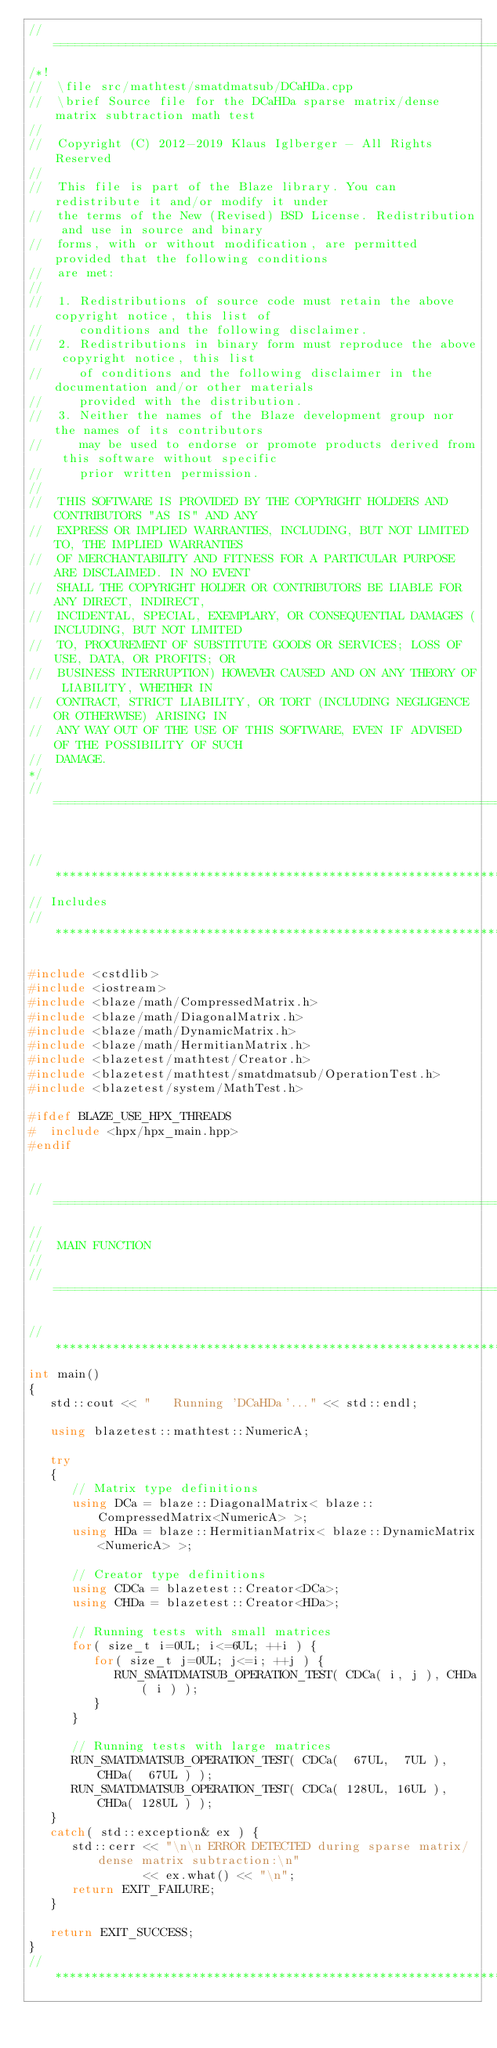<code> <loc_0><loc_0><loc_500><loc_500><_C++_>//=================================================================================================
/*!
//  \file src/mathtest/smatdmatsub/DCaHDa.cpp
//  \brief Source file for the DCaHDa sparse matrix/dense matrix subtraction math test
//
//  Copyright (C) 2012-2019 Klaus Iglberger - All Rights Reserved
//
//  This file is part of the Blaze library. You can redistribute it and/or modify it under
//  the terms of the New (Revised) BSD License. Redistribution and use in source and binary
//  forms, with or without modification, are permitted provided that the following conditions
//  are met:
//
//  1. Redistributions of source code must retain the above copyright notice, this list of
//     conditions and the following disclaimer.
//  2. Redistributions in binary form must reproduce the above copyright notice, this list
//     of conditions and the following disclaimer in the documentation and/or other materials
//     provided with the distribution.
//  3. Neither the names of the Blaze development group nor the names of its contributors
//     may be used to endorse or promote products derived from this software without specific
//     prior written permission.
//
//  THIS SOFTWARE IS PROVIDED BY THE COPYRIGHT HOLDERS AND CONTRIBUTORS "AS IS" AND ANY
//  EXPRESS OR IMPLIED WARRANTIES, INCLUDING, BUT NOT LIMITED TO, THE IMPLIED WARRANTIES
//  OF MERCHANTABILITY AND FITNESS FOR A PARTICULAR PURPOSE ARE DISCLAIMED. IN NO EVENT
//  SHALL THE COPYRIGHT HOLDER OR CONTRIBUTORS BE LIABLE FOR ANY DIRECT, INDIRECT,
//  INCIDENTAL, SPECIAL, EXEMPLARY, OR CONSEQUENTIAL DAMAGES (INCLUDING, BUT NOT LIMITED
//  TO, PROCUREMENT OF SUBSTITUTE GOODS OR SERVICES; LOSS OF USE, DATA, OR PROFITS; OR
//  BUSINESS INTERRUPTION) HOWEVER CAUSED AND ON ANY THEORY OF LIABILITY, WHETHER IN
//  CONTRACT, STRICT LIABILITY, OR TORT (INCLUDING NEGLIGENCE OR OTHERWISE) ARISING IN
//  ANY WAY OUT OF THE USE OF THIS SOFTWARE, EVEN IF ADVISED OF THE POSSIBILITY OF SUCH
//  DAMAGE.
*/
//=================================================================================================


//*************************************************************************************************
// Includes
//*************************************************************************************************

#include <cstdlib>
#include <iostream>
#include <blaze/math/CompressedMatrix.h>
#include <blaze/math/DiagonalMatrix.h>
#include <blaze/math/DynamicMatrix.h>
#include <blaze/math/HermitianMatrix.h>
#include <blazetest/mathtest/Creator.h>
#include <blazetest/mathtest/smatdmatsub/OperationTest.h>
#include <blazetest/system/MathTest.h>

#ifdef BLAZE_USE_HPX_THREADS
#  include <hpx/hpx_main.hpp>
#endif


//=================================================================================================
//
//  MAIN FUNCTION
//
//=================================================================================================

//*************************************************************************************************
int main()
{
   std::cout << "   Running 'DCaHDa'..." << std::endl;

   using blazetest::mathtest::NumericA;

   try
   {
      // Matrix type definitions
      using DCa = blaze::DiagonalMatrix< blaze::CompressedMatrix<NumericA> >;
      using HDa = blaze::HermitianMatrix< blaze::DynamicMatrix<NumericA> >;

      // Creator type definitions
      using CDCa = blazetest::Creator<DCa>;
      using CHDa = blazetest::Creator<HDa>;

      // Running tests with small matrices
      for( size_t i=0UL; i<=6UL; ++i ) {
         for( size_t j=0UL; j<=i; ++j ) {
            RUN_SMATDMATSUB_OPERATION_TEST( CDCa( i, j ), CHDa( i ) );
         }
      }

      // Running tests with large matrices
      RUN_SMATDMATSUB_OPERATION_TEST( CDCa(  67UL,  7UL ), CHDa(  67UL ) );
      RUN_SMATDMATSUB_OPERATION_TEST( CDCa( 128UL, 16UL ), CHDa( 128UL ) );
   }
   catch( std::exception& ex ) {
      std::cerr << "\n\n ERROR DETECTED during sparse matrix/dense matrix subtraction:\n"
                << ex.what() << "\n";
      return EXIT_FAILURE;
   }

   return EXIT_SUCCESS;
}
//*************************************************************************************************
</code> 